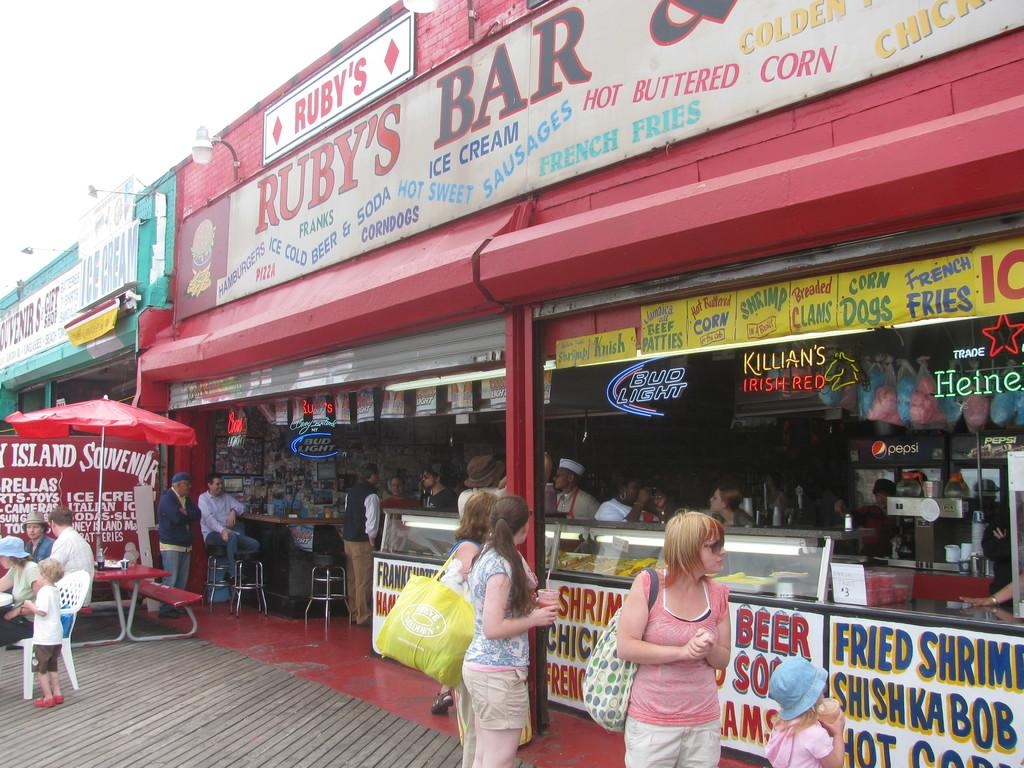<image>
Provide a brief description of the given image. A building front has a sign that says Ruby's Bar above it. 